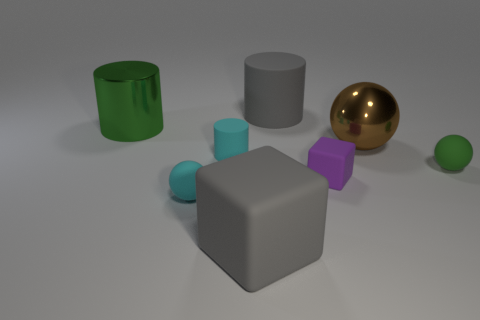Add 1 small blocks. How many objects exist? 9 Subtract 0 yellow blocks. How many objects are left? 8 Subtract all balls. How many objects are left? 5 Subtract all brown spheres. Subtract all small balls. How many objects are left? 5 Add 7 tiny cylinders. How many tiny cylinders are left? 8 Add 2 tiny shiny things. How many tiny shiny things exist? 2 